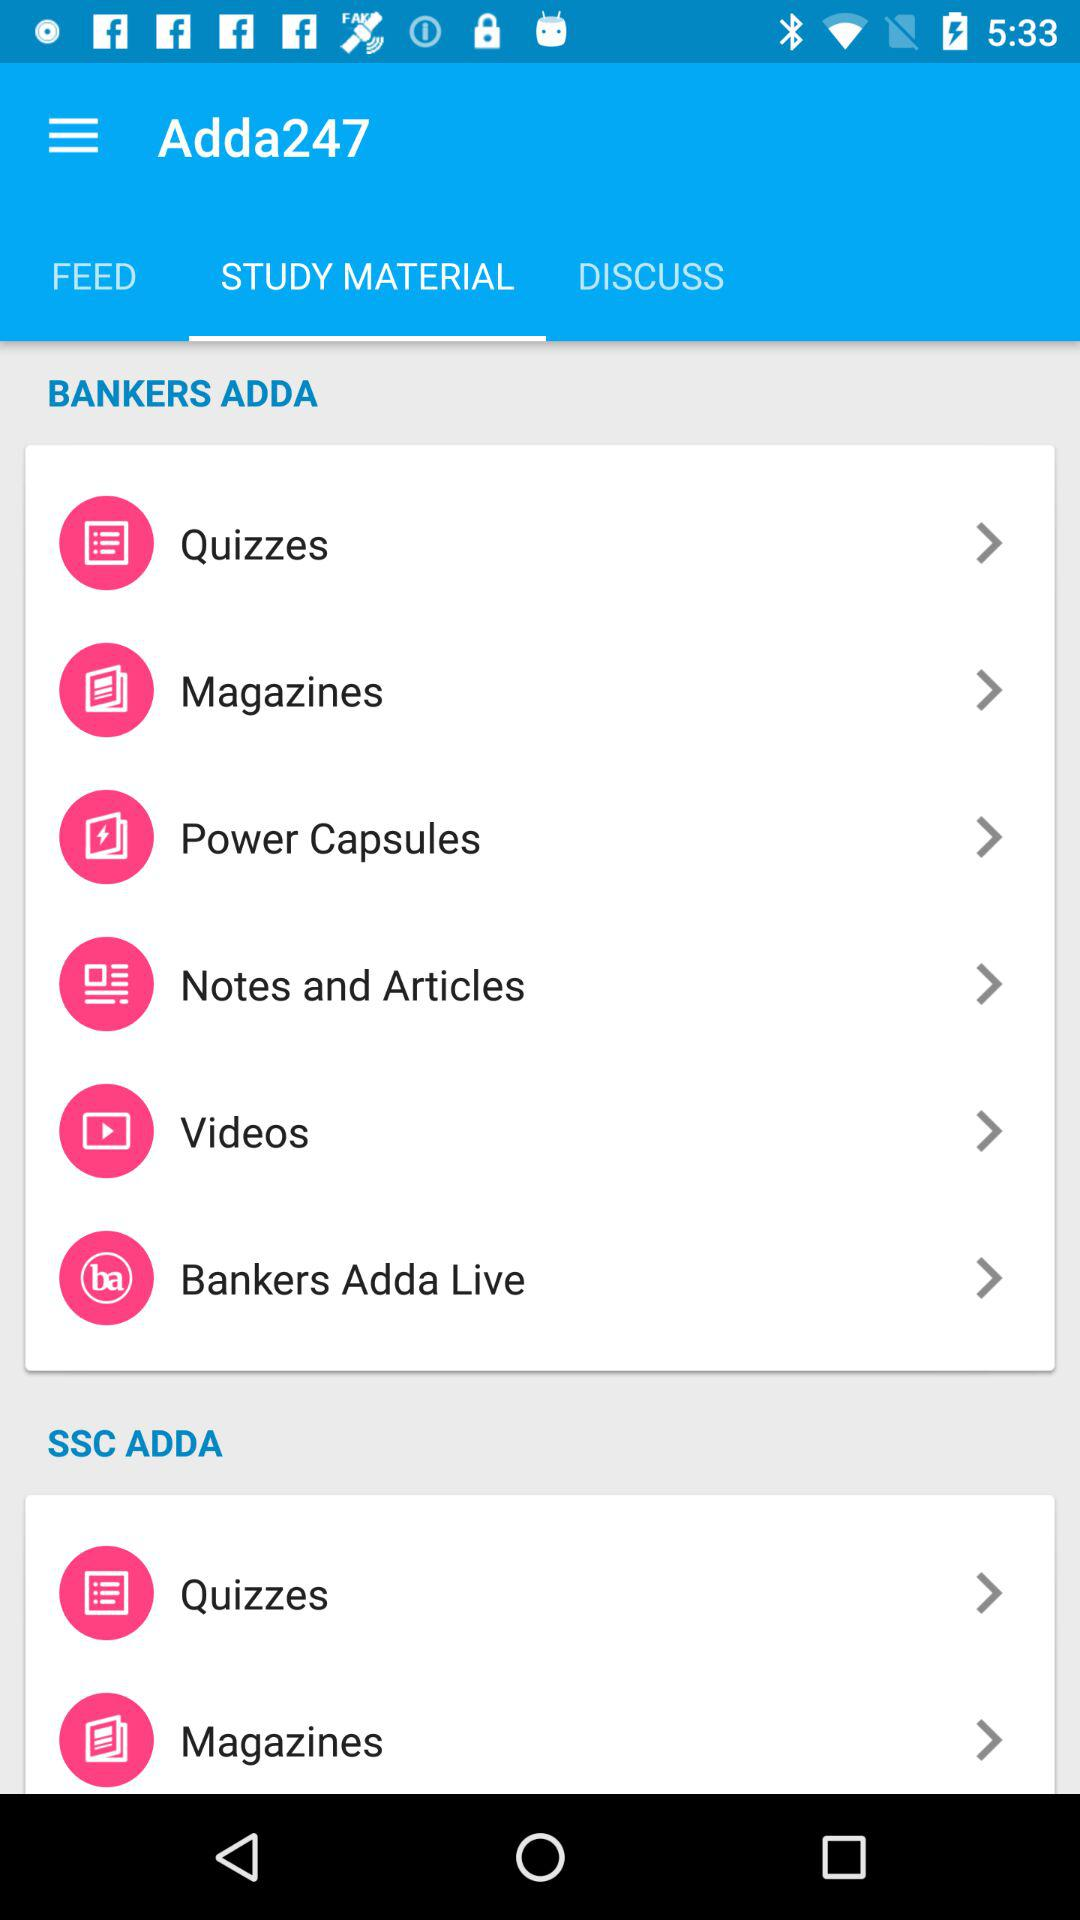Which tab is selected? The selected tab is study material. 